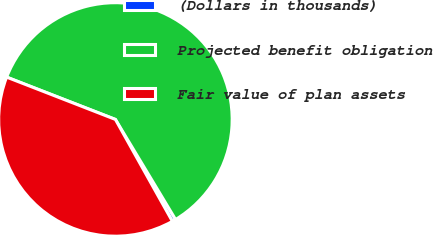Convert chart to OTSL. <chart><loc_0><loc_0><loc_500><loc_500><pie_chart><fcel>(Dollars in thousands)<fcel>Projected benefit obligation<fcel>Fair value of plan assets<nl><fcel>0.5%<fcel>60.48%<fcel>39.02%<nl></chart> 